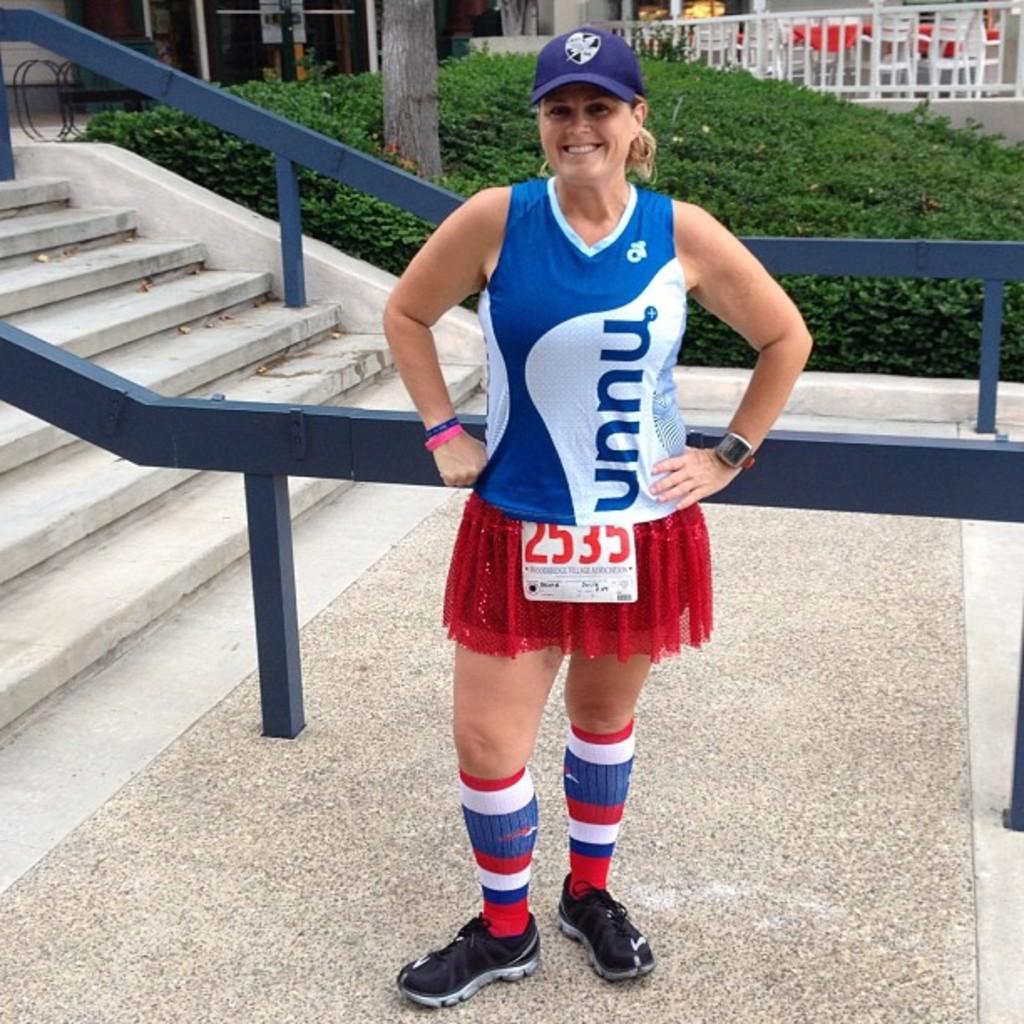<image>
Write a terse but informative summary of the picture. A woman wearing a vnnu sports shirt and standing by the stairs. 